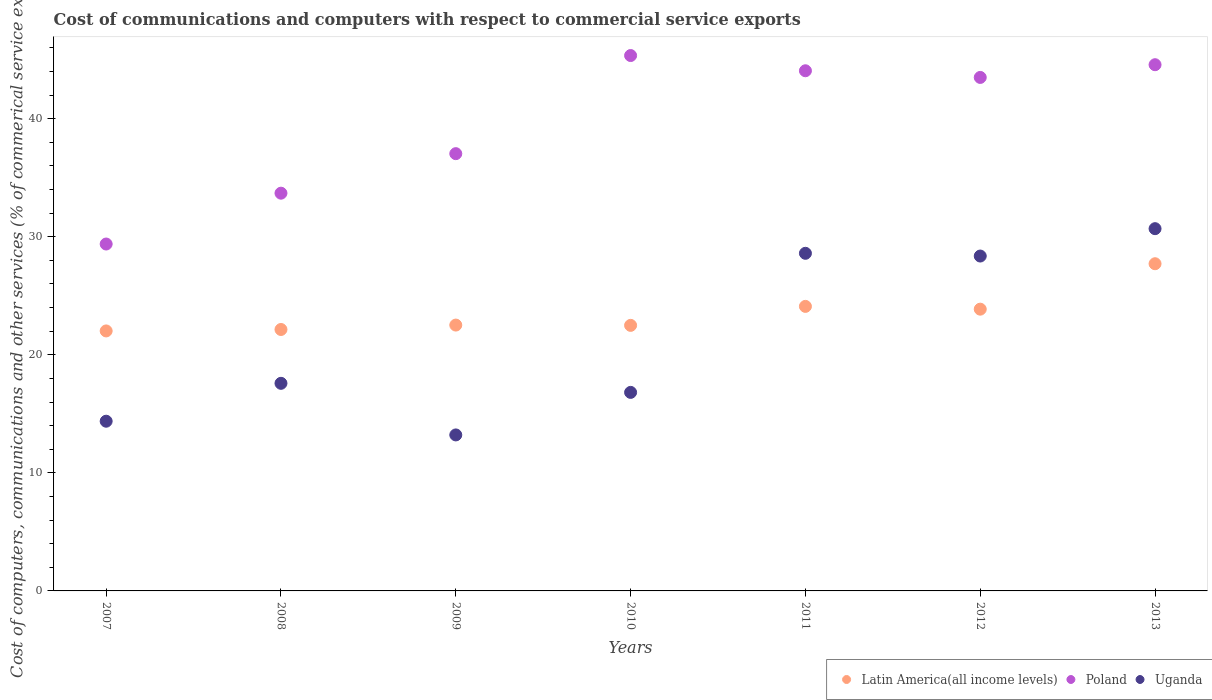How many different coloured dotlines are there?
Provide a succinct answer. 3. What is the cost of communications and computers in Uganda in 2009?
Offer a very short reply. 13.21. Across all years, what is the maximum cost of communications and computers in Uganda?
Provide a succinct answer. 30.69. Across all years, what is the minimum cost of communications and computers in Uganda?
Provide a succinct answer. 13.21. In which year was the cost of communications and computers in Uganda minimum?
Ensure brevity in your answer.  2009. What is the total cost of communications and computers in Latin America(all income levels) in the graph?
Offer a very short reply. 164.87. What is the difference between the cost of communications and computers in Latin America(all income levels) in 2010 and that in 2011?
Your answer should be compact. -1.61. What is the difference between the cost of communications and computers in Uganda in 2013 and the cost of communications and computers in Latin America(all income levels) in 2009?
Your answer should be very brief. 8.17. What is the average cost of communications and computers in Poland per year?
Offer a terse response. 39.66. In the year 2013, what is the difference between the cost of communications and computers in Poland and cost of communications and computers in Uganda?
Provide a short and direct response. 13.89. What is the ratio of the cost of communications and computers in Poland in 2008 to that in 2013?
Ensure brevity in your answer.  0.76. What is the difference between the highest and the second highest cost of communications and computers in Latin America(all income levels)?
Make the answer very short. 3.61. What is the difference between the highest and the lowest cost of communications and computers in Poland?
Provide a succinct answer. 15.97. In how many years, is the cost of communications and computers in Uganda greater than the average cost of communications and computers in Uganda taken over all years?
Your answer should be compact. 3. Is the sum of the cost of communications and computers in Latin America(all income levels) in 2008 and 2012 greater than the maximum cost of communications and computers in Poland across all years?
Give a very brief answer. Yes. Is it the case that in every year, the sum of the cost of communications and computers in Poland and cost of communications and computers in Uganda  is greater than the cost of communications and computers in Latin America(all income levels)?
Your answer should be compact. Yes. Does the cost of communications and computers in Latin America(all income levels) monotonically increase over the years?
Provide a short and direct response. No. Is the cost of communications and computers in Poland strictly greater than the cost of communications and computers in Uganda over the years?
Your answer should be compact. Yes. Is the cost of communications and computers in Poland strictly less than the cost of communications and computers in Uganda over the years?
Provide a succinct answer. No. How many dotlines are there?
Offer a very short reply. 3. How many years are there in the graph?
Offer a very short reply. 7. What is the difference between two consecutive major ticks on the Y-axis?
Your answer should be compact. 10. Where does the legend appear in the graph?
Provide a short and direct response. Bottom right. How are the legend labels stacked?
Keep it short and to the point. Horizontal. What is the title of the graph?
Keep it short and to the point. Cost of communications and computers with respect to commercial service exports. Does "European Union" appear as one of the legend labels in the graph?
Your answer should be compact. No. What is the label or title of the X-axis?
Ensure brevity in your answer.  Years. What is the label or title of the Y-axis?
Make the answer very short. Cost of computers, communications and other services (% of commerical service exports). What is the Cost of computers, communications and other services (% of commerical service exports) of Latin America(all income levels) in 2007?
Keep it short and to the point. 22.02. What is the Cost of computers, communications and other services (% of commerical service exports) in Poland in 2007?
Keep it short and to the point. 29.39. What is the Cost of computers, communications and other services (% of commerical service exports) of Uganda in 2007?
Provide a succinct answer. 14.38. What is the Cost of computers, communications and other services (% of commerical service exports) of Latin America(all income levels) in 2008?
Ensure brevity in your answer.  22.15. What is the Cost of computers, communications and other services (% of commerical service exports) of Poland in 2008?
Your answer should be very brief. 33.69. What is the Cost of computers, communications and other services (% of commerical service exports) of Uganda in 2008?
Give a very brief answer. 17.59. What is the Cost of computers, communications and other services (% of commerical service exports) in Latin America(all income levels) in 2009?
Your answer should be very brief. 22.52. What is the Cost of computers, communications and other services (% of commerical service exports) in Poland in 2009?
Offer a terse response. 37.04. What is the Cost of computers, communications and other services (% of commerical service exports) in Uganda in 2009?
Your answer should be compact. 13.21. What is the Cost of computers, communications and other services (% of commerical service exports) of Latin America(all income levels) in 2010?
Give a very brief answer. 22.5. What is the Cost of computers, communications and other services (% of commerical service exports) of Poland in 2010?
Keep it short and to the point. 45.35. What is the Cost of computers, communications and other services (% of commerical service exports) of Uganda in 2010?
Your answer should be very brief. 16.82. What is the Cost of computers, communications and other services (% of commerical service exports) of Latin America(all income levels) in 2011?
Your answer should be compact. 24.1. What is the Cost of computers, communications and other services (% of commerical service exports) of Poland in 2011?
Make the answer very short. 44.06. What is the Cost of computers, communications and other services (% of commerical service exports) of Uganda in 2011?
Your answer should be compact. 28.6. What is the Cost of computers, communications and other services (% of commerical service exports) of Latin America(all income levels) in 2012?
Give a very brief answer. 23.87. What is the Cost of computers, communications and other services (% of commerical service exports) of Poland in 2012?
Offer a terse response. 43.5. What is the Cost of computers, communications and other services (% of commerical service exports) of Uganda in 2012?
Offer a very short reply. 28.37. What is the Cost of computers, communications and other services (% of commerical service exports) of Latin America(all income levels) in 2013?
Provide a short and direct response. 27.72. What is the Cost of computers, communications and other services (% of commerical service exports) in Poland in 2013?
Provide a succinct answer. 44.58. What is the Cost of computers, communications and other services (% of commerical service exports) of Uganda in 2013?
Give a very brief answer. 30.69. Across all years, what is the maximum Cost of computers, communications and other services (% of commerical service exports) in Latin America(all income levels)?
Provide a short and direct response. 27.72. Across all years, what is the maximum Cost of computers, communications and other services (% of commerical service exports) in Poland?
Provide a short and direct response. 45.35. Across all years, what is the maximum Cost of computers, communications and other services (% of commerical service exports) of Uganda?
Give a very brief answer. 30.69. Across all years, what is the minimum Cost of computers, communications and other services (% of commerical service exports) in Latin America(all income levels)?
Provide a succinct answer. 22.02. Across all years, what is the minimum Cost of computers, communications and other services (% of commerical service exports) of Poland?
Offer a very short reply. 29.39. Across all years, what is the minimum Cost of computers, communications and other services (% of commerical service exports) of Uganda?
Offer a very short reply. 13.21. What is the total Cost of computers, communications and other services (% of commerical service exports) in Latin America(all income levels) in the graph?
Make the answer very short. 164.87. What is the total Cost of computers, communications and other services (% of commerical service exports) in Poland in the graph?
Ensure brevity in your answer.  277.61. What is the total Cost of computers, communications and other services (% of commerical service exports) of Uganda in the graph?
Provide a succinct answer. 149.65. What is the difference between the Cost of computers, communications and other services (% of commerical service exports) in Latin America(all income levels) in 2007 and that in 2008?
Offer a very short reply. -0.12. What is the difference between the Cost of computers, communications and other services (% of commerical service exports) of Poland in 2007 and that in 2008?
Provide a succinct answer. -4.31. What is the difference between the Cost of computers, communications and other services (% of commerical service exports) in Uganda in 2007 and that in 2008?
Offer a terse response. -3.21. What is the difference between the Cost of computers, communications and other services (% of commerical service exports) in Latin America(all income levels) in 2007 and that in 2009?
Offer a terse response. -0.5. What is the difference between the Cost of computers, communications and other services (% of commerical service exports) in Poland in 2007 and that in 2009?
Ensure brevity in your answer.  -7.65. What is the difference between the Cost of computers, communications and other services (% of commerical service exports) of Uganda in 2007 and that in 2009?
Offer a very short reply. 1.16. What is the difference between the Cost of computers, communications and other services (% of commerical service exports) in Latin America(all income levels) in 2007 and that in 2010?
Keep it short and to the point. -0.47. What is the difference between the Cost of computers, communications and other services (% of commerical service exports) in Poland in 2007 and that in 2010?
Give a very brief answer. -15.97. What is the difference between the Cost of computers, communications and other services (% of commerical service exports) of Uganda in 2007 and that in 2010?
Give a very brief answer. -2.44. What is the difference between the Cost of computers, communications and other services (% of commerical service exports) of Latin America(all income levels) in 2007 and that in 2011?
Ensure brevity in your answer.  -2.08. What is the difference between the Cost of computers, communications and other services (% of commerical service exports) in Poland in 2007 and that in 2011?
Give a very brief answer. -14.68. What is the difference between the Cost of computers, communications and other services (% of commerical service exports) in Uganda in 2007 and that in 2011?
Make the answer very short. -14.22. What is the difference between the Cost of computers, communications and other services (% of commerical service exports) in Latin America(all income levels) in 2007 and that in 2012?
Offer a very short reply. -1.84. What is the difference between the Cost of computers, communications and other services (% of commerical service exports) in Poland in 2007 and that in 2012?
Your answer should be compact. -14.11. What is the difference between the Cost of computers, communications and other services (% of commerical service exports) in Uganda in 2007 and that in 2012?
Your answer should be very brief. -13.99. What is the difference between the Cost of computers, communications and other services (% of commerical service exports) of Latin America(all income levels) in 2007 and that in 2013?
Provide a short and direct response. -5.69. What is the difference between the Cost of computers, communications and other services (% of commerical service exports) of Poland in 2007 and that in 2013?
Provide a short and direct response. -15.19. What is the difference between the Cost of computers, communications and other services (% of commerical service exports) in Uganda in 2007 and that in 2013?
Make the answer very short. -16.31. What is the difference between the Cost of computers, communications and other services (% of commerical service exports) in Latin America(all income levels) in 2008 and that in 2009?
Offer a terse response. -0.37. What is the difference between the Cost of computers, communications and other services (% of commerical service exports) of Poland in 2008 and that in 2009?
Provide a short and direct response. -3.35. What is the difference between the Cost of computers, communications and other services (% of commerical service exports) of Uganda in 2008 and that in 2009?
Your response must be concise. 4.37. What is the difference between the Cost of computers, communications and other services (% of commerical service exports) in Latin America(all income levels) in 2008 and that in 2010?
Your answer should be very brief. -0.35. What is the difference between the Cost of computers, communications and other services (% of commerical service exports) of Poland in 2008 and that in 2010?
Ensure brevity in your answer.  -11.66. What is the difference between the Cost of computers, communications and other services (% of commerical service exports) in Uganda in 2008 and that in 2010?
Your response must be concise. 0.77. What is the difference between the Cost of computers, communications and other services (% of commerical service exports) in Latin America(all income levels) in 2008 and that in 2011?
Ensure brevity in your answer.  -1.96. What is the difference between the Cost of computers, communications and other services (% of commerical service exports) of Poland in 2008 and that in 2011?
Keep it short and to the point. -10.37. What is the difference between the Cost of computers, communications and other services (% of commerical service exports) of Uganda in 2008 and that in 2011?
Provide a short and direct response. -11.01. What is the difference between the Cost of computers, communications and other services (% of commerical service exports) of Latin America(all income levels) in 2008 and that in 2012?
Ensure brevity in your answer.  -1.72. What is the difference between the Cost of computers, communications and other services (% of commerical service exports) of Poland in 2008 and that in 2012?
Ensure brevity in your answer.  -9.81. What is the difference between the Cost of computers, communications and other services (% of commerical service exports) in Uganda in 2008 and that in 2012?
Offer a terse response. -10.78. What is the difference between the Cost of computers, communications and other services (% of commerical service exports) in Latin America(all income levels) in 2008 and that in 2013?
Make the answer very short. -5.57. What is the difference between the Cost of computers, communications and other services (% of commerical service exports) in Poland in 2008 and that in 2013?
Provide a short and direct response. -10.88. What is the difference between the Cost of computers, communications and other services (% of commerical service exports) of Uganda in 2008 and that in 2013?
Ensure brevity in your answer.  -13.1. What is the difference between the Cost of computers, communications and other services (% of commerical service exports) in Latin America(all income levels) in 2009 and that in 2010?
Give a very brief answer. 0.02. What is the difference between the Cost of computers, communications and other services (% of commerical service exports) in Poland in 2009 and that in 2010?
Your answer should be very brief. -8.31. What is the difference between the Cost of computers, communications and other services (% of commerical service exports) of Uganda in 2009 and that in 2010?
Ensure brevity in your answer.  -3.6. What is the difference between the Cost of computers, communications and other services (% of commerical service exports) in Latin America(all income levels) in 2009 and that in 2011?
Your answer should be very brief. -1.58. What is the difference between the Cost of computers, communications and other services (% of commerical service exports) of Poland in 2009 and that in 2011?
Keep it short and to the point. -7.02. What is the difference between the Cost of computers, communications and other services (% of commerical service exports) of Uganda in 2009 and that in 2011?
Ensure brevity in your answer.  -15.38. What is the difference between the Cost of computers, communications and other services (% of commerical service exports) of Latin America(all income levels) in 2009 and that in 2012?
Provide a short and direct response. -1.35. What is the difference between the Cost of computers, communications and other services (% of commerical service exports) in Poland in 2009 and that in 2012?
Give a very brief answer. -6.46. What is the difference between the Cost of computers, communications and other services (% of commerical service exports) in Uganda in 2009 and that in 2012?
Your answer should be compact. -15.15. What is the difference between the Cost of computers, communications and other services (% of commerical service exports) of Latin America(all income levels) in 2009 and that in 2013?
Provide a succinct answer. -5.2. What is the difference between the Cost of computers, communications and other services (% of commerical service exports) of Poland in 2009 and that in 2013?
Provide a short and direct response. -7.53. What is the difference between the Cost of computers, communications and other services (% of commerical service exports) in Uganda in 2009 and that in 2013?
Your answer should be compact. -17.47. What is the difference between the Cost of computers, communications and other services (% of commerical service exports) of Latin America(all income levels) in 2010 and that in 2011?
Give a very brief answer. -1.61. What is the difference between the Cost of computers, communications and other services (% of commerical service exports) of Poland in 2010 and that in 2011?
Provide a succinct answer. 1.29. What is the difference between the Cost of computers, communications and other services (% of commerical service exports) in Uganda in 2010 and that in 2011?
Provide a short and direct response. -11.78. What is the difference between the Cost of computers, communications and other services (% of commerical service exports) of Latin America(all income levels) in 2010 and that in 2012?
Give a very brief answer. -1.37. What is the difference between the Cost of computers, communications and other services (% of commerical service exports) in Poland in 2010 and that in 2012?
Offer a very short reply. 1.85. What is the difference between the Cost of computers, communications and other services (% of commerical service exports) of Uganda in 2010 and that in 2012?
Make the answer very short. -11.55. What is the difference between the Cost of computers, communications and other services (% of commerical service exports) of Latin America(all income levels) in 2010 and that in 2013?
Your answer should be very brief. -5.22. What is the difference between the Cost of computers, communications and other services (% of commerical service exports) in Poland in 2010 and that in 2013?
Your answer should be compact. 0.78. What is the difference between the Cost of computers, communications and other services (% of commerical service exports) in Uganda in 2010 and that in 2013?
Provide a short and direct response. -13.87. What is the difference between the Cost of computers, communications and other services (% of commerical service exports) of Latin America(all income levels) in 2011 and that in 2012?
Make the answer very short. 0.24. What is the difference between the Cost of computers, communications and other services (% of commerical service exports) of Poland in 2011 and that in 2012?
Offer a very short reply. 0.56. What is the difference between the Cost of computers, communications and other services (% of commerical service exports) in Uganda in 2011 and that in 2012?
Offer a very short reply. 0.23. What is the difference between the Cost of computers, communications and other services (% of commerical service exports) of Latin America(all income levels) in 2011 and that in 2013?
Your answer should be compact. -3.61. What is the difference between the Cost of computers, communications and other services (% of commerical service exports) of Poland in 2011 and that in 2013?
Ensure brevity in your answer.  -0.51. What is the difference between the Cost of computers, communications and other services (% of commerical service exports) of Uganda in 2011 and that in 2013?
Keep it short and to the point. -2.09. What is the difference between the Cost of computers, communications and other services (% of commerical service exports) of Latin America(all income levels) in 2012 and that in 2013?
Provide a short and direct response. -3.85. What is the difference between the Cost of computers, communications and other services (% of commerical service exports) of Poland in 2012 and that in 2013?
Your answer should be compact. -1.08. What is the difference between the Cost of computers, communications and other services (% of commerical service exports) in Uganda in 2012 and that in 2013?
Make the answer very short. -2.32. What is the difference between the Cost of computers, communications and other services (% of commerical service exports) in Latin America(all income levels) in 2007 and the Cost of computers, communications and other services (% of commerical service exports) in Poland in 2008?
Keep it short and to the point. -11.67. What is the difference between the Cost of computers, communications and other services (% of commerical service exports) of Latin America(all income levels) in 2007 and the Cost of computers, communications and other services (% of commerical service exports) of Uganda in 2008?
Ensure brevity in your answer.  4.44. What is the difference between the Cost of computers, communications and other services (% of commerical service exports) in Poland in 2007 and the Cost of computers, communications and other services (% of commerical service exports) in Uganda in 2008?
Offer a terse response. 11.8. What is the difference between the Cost of computers, communications and other services (% of commerical service exports) of Latin America(all income levels) in 2007 and the Cost of computers, communications and other services (% of commerical service exports) of Poland in 2009?
Offer a very short reply. -15.02. What is the difference between the Cost of computers, communications and other services (% of commerical service exports) of Latin America(all income levels) in 2007 and the Cost of computers, communications and other services (% of commerical service exports) of Uganda in 2009?
Keep it short and to the point. 8.81. What is the difference between the Cost of computers, communications and other services (% of commerical service exports) of Poland in 2007 and the Cost of computers, communications and other services (% of commerical service exports) of Uganda in 2009?
Ensure brevity in your answer.  16.17. What is the difference between the Cost of computers, communications and other services (% of commerical service exports) in Latin America(all income levels) in 2007 and the Cost of computers, communications and other services (% of commerical service exports) in Poland in 2010?
Provide a succinct answer. -23.33. What is the difference between the Cost of computers, communications and other services (% of commerical service exports) in Latin America(all income levels) in 2007 and the Cost of computers, communications and other services (% of commerical service exports) in Uganda in 2010?
Give a very brief answer. 5.21. What is the difference between the Cost of computers, communications and other services (% of commerical service exports) of Poland in 2007 and the Cost of computers, communications and other services (% of commerical service exports) of Uganda in 2010?
Keep it short and to the point. 12.57. What is the difference between the Cost of computers, communications and other services (% of commerical service exports) of Latin America(all income levels) in 2007 and the Cost of computers, communications and other services (% of commerical service exports) of Poland in 2011?
Your answer should be compact. -22.04. What is the difference between the Cost of computers, communications and other services (% of commerical service exports) in Latin America(all income levels) in 2007 and the Cost of computers, communications and other services (% of commerical service exports) in Uganda in 2011?
Your response must be concise. -6.58. What is the difference between the Cost of computers, communications and other services (% of commerical service exports) in Poland in 2007 and the Cost of computers, communications and other services (% of commerical service exports) in Uganda in 2011?
Your answer should be compact. 0.79. What is the difference between the Cost of computers, communications and other services (% of commerical service exports) in Latin America(all income levels) in 2007 and the Cost of computers, communications and other services (% of commerical service exports) in Poland in 2012?
Give a very brief answer. -21.47. What is the difference between the Cost of computers, communications and other services (% of commerical service exports) in Latin America(all income levels) in 2007 and the Cost of computers, communications and other services (% of commerical service exports) in Uganda in 2012?
Offer a very short reply. -6.34. What is the difference between the Cost of computers, communications and other services (% of commerical service exports) of Poland in 2007 and the Cost of computers, communications and other services (% of commerical service exports) of Uganda in 2012?
Ensure brevity in your answer.  1.02. What is the difference between the Cost of computers, communications and other services (% of commerical service exports) in Latin America(all income levels) in 2007 and the Cost of computers, communications and other services (% of commerical service exports) in Poland in 2013?
Keep it short and to the point. -22.55. What is the difference between the Cost of computers, communications and other services (% of commerical service exports) of Latin America(all income levels) in 2007 and the Cost of computers, communications and other services (% of commerical service exports) of Uganda in 2013?
Make the answer very short. -8.66. What is the difference between the Cost of computers, communications and other services (% of commerical service exports) in Poland in 2007 and the Cost of computers, communications and other services (% of commerical service exports) in Uganda in 2013?
Your answer should be very brief. -1.3. What is the difference between the Cost of computers, communications and other services (% of commerical service exports) in Latin America(all income levels) in 2008 and the Cost of computers, communications and other services (% of commerical service exports) in Poland in 2009?
Provide a short and direct response. -14.89. What is the difference between the Cost of computers, communications and other services (% of commerical service exports) in Latin America(all income levels) in 2008 and the Cost of computers, communications and other services (% of commerical service exports) in Uganda in 2009?
Provide a short and direct response. 8.93. What is the difference between the Cost of computers, communications and other services (% of commerical service exports) of Poland in 2008 and the Cost of computers, communications and other services (% of commerical service exports) of Uganda in 2009?
Offer a very short reply. 20.48. What is the difference between the Cost of computers, communications and other services (% of commerical service exports) of Latin America(all income levels) in 2008 and the Cost of computers, communications and other services (% of commerical service exports) of Poland in 2010?
Give a very brief answer. -23.21. What is the difference between the Cost of computers, communications and other services (% of commerical service exports) in Latin America(all income levels) in 2008 and the Cost of computers, communications and other services (% of commerical service exports) in Uganda in 2010?
Your response must be concise. 5.33. What is the difference between the Cost of computers, communications and other services (% of commerical service exports) in Poland in 2008 and the Cost of computers, communications and other services (% of commerical service exports) in Uganda in 2010?
Offer a very short reply. 16.87. What is the difference between the Cost of computers, communications and other services (% of commerical service exports) in Latin America(all income levels) in 2008 and the Cost of computers, communications and other services (% of commerical service exports) in Poland in 2011?
Provide a succinct answer. -21.92. What is the difference between the Cost of computers, communications and other services (% of commerical service exports) of Latin America(all income levels) in 2008 and the Cost of computers, communications and other services (% of commerical service exports) of Uganda in 2011?
Make the answer very short. -6.45. What is the difference between the Cost of computers, communications and other services (% of commerical service exports) in Poland in 2008 and the Cost of computers, communications and other services (% of commerical service exports) in Uganda in 2011?
Your answer should be very brief. 5.09. What is the difference between the Cost of computers, communications and other services (% of commerical service exports) in Latin America(all income levels) in 2008 and the Cost of computers, communications and other services (% of commerical service exports) in Poland in 2012?
Give a very brief answer. -21.35. What is the difference between the Cost of computers, communications and other services (% of commerical service exports) of Latin America(all income levels) in 2008 and the Cost of computers, communications and other services (% of commerical service exports) of Uganda in 2012?
Ensure brevity in your answer.  -6.22. What is the difference between the Cost of computers, communications and other services (% of commerical service exports) in Poland in 2008 and the Cost of computers, communications and other services (% of commerical service exports) in Uganda in 2012?
Ensure brevity in your answer.  5.32. What is the difference between the Cost of computers, communications and other services (% of commerical service exports) of Latin America(all income levels) in 2008 and the Cost of computers, communications and other services (% of commerical service exports) of Poland in 2013?
Your answer should be compact. -22.43. What is the difference between the Cost of computers, communications and other services (% of commerical service exports) in Latin America(all income levels) in 2008 and the Cost of computers, communications and other services (% of commerical service exports) in Uganda in 2013?
Give a very brief answer. -8.54. What is the difference between the Cost of computers, communications and other services (% of commerical service exports) of Poland in 2008 and the Cost of computers, communications and other services (% of commerical service exports) of Uganda in 2013?
Your answer should be very brief. 3.01. What is the difference between the Cost of computers, communications and other services (% of commerical service exports) of Latin America(all income levels) in 2009 and the Cost of computers, communications and other services (% of commerical service exports) of Poland in 2010?
Offer a very short reply. -22.83. What is the difference between the Cost of computers, communications and other services (% of commerical service exports) in Latin America(all income levels) in 2009 and the Cost of computers, communications and other services (% of commerical service exports) in Uganda in 2010?
Keep it short and to the point. 5.7. What is the difference between the Cost of computers, communications and other services (% of commerical service exports) of Poland in 2009 and the Cost of computers, communications and other services (% of commerical service exports) of Uganda in 2010?
Your answer should be compact. 20.22. What is the difference between the Cost of computers, communications and other services (% of commerical service exports) of Latin America(all income levels) in 2009 and the Cost of computers, communications and other services (% of commerical service exports) of Poland in 2011?
Keep it short and to the point. -21.54. What is the difference between the Cost of computers, communications and other services (% of commerical service exports) in Latin America(all income levels) in 2009 and the Cost of computers, communications and other services (% of commerical service exports) in Uganda in 2011?
Give a very brief answer. -6.08. What is the difference between the Cost of computers, communications and other services (% of commerical service exports) in Poland in 2009 and the Cost of computers, communications and other services (% of commerical service exports) in Uganda in 2011?
Ensure brevity in your answer.  8.44. What is the difference between the Cost of computers, communications and other services (% of commerical service exports) in Latin America(all income levels) in 2009 and the Cost of computers, communications and other services (% of commerical service exports) in Poland in 2012?
Ensure brevity in your answer.  -20.98. What is the difference between the Cost of computers, communications and other services (% of commerical service exports) in Latin America(all income levels) in 2009 and the Cost of computers, communications and other services (% of commerical service exports) in Uganda in 2012?
Your answer should be compact. -5.85. What is the difference between the Cost of computers, communications and other services (% of commerical service exports) of Poland in 2009 and the Cost of computers, communications and other services (% of commerical service exports) of Uganda in 2012?
Ensure brevity in your answer.  8.67. What is the difference between the Cost of computers, communications and other services (% of commerical service exports) in Latin America(all income levels) in 2009 and the Cost of computers, communications and other services (% of commerical service exports) in Poland in 2013?
Give a very brief answer. -22.06. What is the difference between the Cost of computers, communications and other services (% of commerical service exports) in Latin America(all income levels) in 2009 and the Cost of computers, communications and other services (% of commerical service exports) in Uganda in 2013?
Keep it short and to the point. -8.17. What is the difference between the Cost of computers, communications and other services (% of commerical service exports) of Poland in 2009 and the Cost of computers, communications and other services (% of commerical service exports) of Uganda in 2013?
Keep it short and to the point. 6.35. What is the difference between the Cost of computers, communications and other services (% of commerical service exports) of Latin America(all income levels) in 2010 and the Cost of computers, communications and other services (% of commerical service exports) of Poland in 2011?
Offer a terse response. -21.57. What is the difference between the Cost of computers, communications and other services (% of commerical service exports) of Latin America(all income levels) in 2010 and the Cost of computers, communications and other services (% of commerical service exports) of Uganda in 2011?
Offer a very short reply. -6.1. What is the difference between the Cost of computers, communications and other services (% of commerical service exports) of Poland in 2010 and the Cost of computers, communications and other services (% of commerical service exports) of Uganda in 2011?
Keep it short and to the point. 16.75. What is the difference between the Cost of computers, communications and other services (% of commerical service exports) in Latin America(all income levels) in 2010 and the Cost of computers, communications and other services (% of commerical service exports) in Poland in 2012?
Your answer should be very brief. -21. What is the difference between the Cost of computers, communications and other services (% of commerical service exports) in Latin America(all income levels) in 2010 and the Cost of computers, communications and other services (% of commerical service exports) in Uganda in 2012?
Offer a very short reply. -5.87. What is the difference between the Cost of computers, communications and other services (% of commerical service exports) of Poland in 2010 and the Cost of computers, communications and other services (% of commerical service exports) of Uganda in 2012?
Provide a succinct answer. 16.98. What is the difference between the Cost of computers, communications and other services (% of commerical service exports) in Latin America(all income levels) in 2010 and the Cost of computers, communications and other services (% of commerical service exports) in Poland in 2013?
Your answer should be compact. -22.08. What is the difference between the Cost of computers, communications and other services (% of commerical service exports) in Latin America(all income levels) in 2010 and the Cost of computers, communications and other services (% of commerical service exports) in Uganda in 2013?
Keep it short and to the point. -8.19. What is the difference between the Cost of computers, communications and other services (% of commerical service exports) in Poland in 2010 and the Cost of computers, communications and other services (% of commerical service exports) in Uganda in 2013?
Make the answer very short. 14.67. What is the difference between the Cost of computers, communications and other services (% of commerical service exports) in Latin America(all income levels) in 2011 and the Cost of computers, communications and other services (% of commerical service exports) in Poland in 2012?
Keep it short and to the point. -19.4. What is the difference between the Cost of computers, communications and other services (% of commerical service exports) in Latin America(all income levels) in 2011 and the Cost of computers, communications and other services (% of commerical service exports) in Uganda in 2012?
Provide a succinct answer. -4.26. What is the difference between the Cost of computers, communications and other services (% of commerical service exports) of Poland in 2011 and the Cost of computers, communications and other services (% of commerical service exports) of Uganda in 2012?
Your response must be concise. 15.69. What is the difference between the Cost of computers, communications and other services (% of commerical service exports) of Latin America(all income levels) in 2011 and the Cost of computers, communications and other services (% of commerical service exports) of Poland in 2013?
Make the answer very short. -20.47. What is the difference between the Cost of computers, communications and other services (% of commerical service exports) of Latin America(all income levels) in 2011 and the Cost of computers, communications and other services (% of commerical service exports) of Uganda in 2013?
Offer a terse response. -6.58. What is the difference between the Cost of computers, communications and other services (% of commerical service exports) in Poland in 2011 and the Cost of computers, communications and other services (% of commerical service exports) in Uganda in 2013?
Your response must be concise. 13.38. What is the difference between the Cost of computers, communications and other services (% of commerical service exports) in Latin America(all income levels) in 2012 and the Cost of computers, communications and other services (% of commerical service exports) in Poland in 2013?
Your response must be concise. -20.71. What is the difference between the Cost of computers, communications and other services (% of commerical service exports) of Latin America(all income levels) in 2012 and the Cost of computers, communications and other services (% of commerical service exports) of Uganda in 2013?
Your response must be concise. -6.82. What is the difference between the Cost of computers, communications and other services (% of commerical service exports) of Poland in 2012 and the Cost of computers, communications and other services (% of commerical service exports) of Uganda in 2013?
Make the answer very short. 12.81. What is the average Cost of computers, communications and other services (% of commerical service exports) in Latin America(all income levels) per year?
Keep it short and to the point. 23.55. What is the average Cost of computers, communications and other services (% of commerical service exports) in Poland per year?
Your response must be concise. 39.66. What is the average Cost of computers, communications and other services (% of commerical service exports) in Uganda per year?
Your answer should be compact. 21.38. In the year 2007, what is the difference between the Cost of computers, communications and other services (% of commerical service exports) of Latin America(all income levels) and Cost of computers, communications and other services (% of commerical service exports) of Poland?
Offer a very short reply. -7.36. In the year 2007, what is the difference between the Cost of computers, communications and other services (% of commerical service exports) of Latin America(all income levels) and Cost of computers, communications and other services (% of commerical service exports) of Uganda?
Your response must be concise. 7.65. In the year 2007, what is the difference between the Cost of computers, communications and other services (% of commerical service exports) in Poland and Cost of computers, communications and other services (% of commerical service exports) in Uganda?
Make the answer very short. 15.01. In the year 2008, what is the difference between the Cost of computers, communications and other services (% of commerical service exports) of Latin America(all income levels) and Cost of computers, communications and other services (% of commerical service exports) of Poland?
Your answer should be very brief. -11.55. In the year 2008, what is the difference between the Cost of computers, communications and other services (% of commerical service exports) in Latin America(all income levels) and Cost of computers, communications and other services (% of commerical service exports) in Uganda?
Keep it short and to the point. 4.56. In the year 2008, what is the difference between the Cost of computers, communications and other services (% of commerical service exports) in Poland and Cost of computers, communications and other services (% of commerical service exports) in Uganda?
Offer a terse response. 16.11. In the year 2009, what is the difference between the Cost of computers, communications and other services (% of commerical service exports) of Latin America(all income levels) and Cost of computers, communications and other services (% of commerical service exports) of Poland?
Your answer should be very brief. -14.52. In the year 2009, what is the difference between the Cost of computers, communications and other services (% of commerical service exports) in Latin America(all income levels) and Cost of computers, communications and other services (% of commerical service exports) in Uganda?
Your answer should be compact. 9.31. In the year 2009, what is the difference between the Cost of computers, communications and other services (% of commerical service exports) of Poland and Cost of computers, communications and other services (% of commerical service exports) of Uganda?
Offer a terse response. 23.83. In the year 2010, what is the difference between the Cost of computers, communications and other services (% of commerical service exports) in Latin America(all income levels) and Cost of computers, communications and other services (% of commerical service exports) in Poland?
Offer a terse response. -22.86. In the year 2010, what is the difference between the Cost of computers, communications and other services (% of commerical service exports) in Latin America(all income levels) and Cost of computers, communications and other services (% of commerical service exports) in Uganda?
Your answer should be very brief. 5.68. In the year 2010, what is the difference between the Cost of computers, communications and other services (% of commerical service exports) in Poland and Cost of computers, communications and other services (% of commerical service exports) in Uganda?
Offer a very short reply. 28.53. In the year 2011, what is the difference between the Cost of computers, communications and other services (% of commerical service exports) of Latin America(all income levels) and Cost of computers, communications and other services (% of commerical service exports) of Poland?
Make the answer very short. -19.96. In the year 2011, what is the difference between the Cost of computers, communications and other services (% of commerical service exports) in Latin America(all income levels) and Cost of computers, communications and other services (% of commerical service exports) in Uganda?
Give a very brief answer. -4.5. In the year 2011, what is the difference between the Cost of computers, communications and other services (% of commerical service exports) of Poland and Cost of computers, communications and other services (% of commerical service exports) of Uganda?
Your answer should be compact. 15.46. In the year 2012, what is the difference between the Cost of computers, communications and other services (% of commerical service exports) of Latin America(all income levels) and Cost of computers, communications and other services (% of commerical service exports) of Poland?
Ensure brevity in your answer.  -19.63. In the year 2012, what is the difference between the Cost of computers, communications and other services (% of commerical service exports) in Latin America(all income levels) and Cost of computers, communications and other services (% of commerical service exports) in Uganda?
Make the answer very short. -4.5. In the year 2012, what is the difference between the Cost of computers, communications and other services (% of commerical service exports) of Poland and Cost of computers, communications and other services (% of commerical service exports) of Uganda?
Give a very brief answer. 15.13. In the year 2013, what is the difference between the Cost of computers, communications and other services (% of commerical service exports) of Latin America(all income levels) and Cost of computers, communications and other services (% of commerical service exports) of Poland?
Provide a short and direct response. -16.86. In the year 2013, what is the difference between the Cost of computers, communications and other services (% of commerical service exports) of Latin America(all income levels) and Cost of computers, communications and other services (% of commerical service exports) of Uganda?
Provide a succinct answer. -2.97. In the year 2013, what is the difference between the Cost of computers, communications and other services (% of commerical service exports) in Poland and Cost of computers, communications and other services (% of commerical service exports) in Uganda?
Keep it short and to the point. 13.89. What is the ratio of the Cost of computers, communications and other services (% of commerical service exports) of Poland in 2007 to that in 2008?
Your answer should be compact. 0.87. What is the ratio of the Cost of computers, communications and other services (% of commerical service exports) in Uganda in 2007 to that in 2008?
Offer a very short reply. 0.82. What is the ratio of the Cost of computers, communications and other services (% of commerical service exports) of Poland in 2007 to that in 2009?
Offer a very short reply. 0.79. What is the ratio of the Cost of computers, communications and other services (% of commerical service exports) in Uganda in 2007 to that in 2009?
Provide a short and direct response. 1.09. What is the ratio of the Cost of computers, communications and other services (% of commerical service exports) in Latin America(all income levels) in 2007 to that in 2010?
Your response must be concise. 0.98. What is the ratio of the Cost of computers, communications and other services (% of commerical service exports) in Poland in 2007 to that in 2010?
Your answer should be very brief. 0.65. What is the ratio of the Cost of computers, communications and other services (% of commerical service exports) of Uganda in 2007 to that in 2010?
Ensure brevity in your answer.  0.85. What is the ratio of the Cost of computers, communications and other services (% of commerical service exports) of Latin America(all income levels) in 2007 to that in 2011?
Your answer should be compact. 0.91. What is the ratio of the Cost of computers, communications and other services (% of commerical service exports) in Poland in 2007 to that in 2011?
Ensure brevity in your answer.  0.67. What is the ratio of the Cost of computers, communications and other services (% of commerical service exports) of Uganda in 2007 to that in 2011?
Ensure brevity in your answer.  0.5. What is the ratio of the Cost of computers, communications and other services (% of commerical service exports) of Latin America(all income levels) in 2007 to that in 2012?
Provide a short and direct response. 0.92. What is the ratio of the Cost of computers, communications and other services (% of commerical service exports) in Poland in 2007 to that in 2012?
Offer a terse response. 0.68. What is the ratio of the Cost of computers, communications and other services (% of commerical service exports) of Uganda in 2007 to that in 2012?
Give a very brief answer. 0.51. What is the ratio of the Cost of computers, communications and other services (% of commerical service exports) of Latin America(all income levels) in 2007 to that in 2013?
Provide a succinct answer. 0.79. What is the ratio of the Cost of computers, communications and other services (% of commerical service exports) in Poland in 2007 to that in 2013?
Provide a short and direct response. 0.66. What is the ratio of the Cost of computers, communications and other services (% of commerical service exports) of Uganda in 2007 to that in 2013?
Keep it short and to the point. 0.47. What is the ratio of the Cost of computers, communications and other services (% of commerical service exports) of Latin America(all income levels) in 2008 to that in 2009?
Your response must be concise. 0.98. What is the ratio of the Cost of computers, communications and other services (% of commerical service exports) of Poland in 2008 to that in 2009?
Offer a terse response. 0.91. What is the ratio of the Cost of computers, communications and other services (% of commerical service exports) of Uganda in 2008 to that in 2009?
Ensure brevity in your answer.  1.33. What is the ratio of the Cost of computers, communications and other services (% of commerical service exports) of Latin America(all income levels) in 2008 to that in 2010?
Provide a short and direct response. 0.98. What is the ratio of the Cost of computers, communications and other services (% of commerical service exports) in Poland in 2008 to that in 2010?
Your response must be concise. 0.74. What is the ratio of the Cost of computers, communications and other services (% of commerical service exports) in Uganda in 2008 to that in 2010?
Offer a terse response. 1.05. What is the ratio of the Cost of computers, communications and other services (% of commerical service exports) of Latin America(all income levels) in 2008 to that in 2011?
Ensure brevity in your answer.  0.92. What is the ratio of the Cost of computers, communications and other services (% of commerical service exports) in Poland in 2008 to that in 2011?
Keep it short and to the point. 0.76. What is the ratio of the Cost of computers, communications and other services (% of commerical service exports) of Uganda in 2008 to that in 2011?
Offer a very short reply. 0.61. What is the ratio of the Cost of computers, communications and other services (% of commerical service exports) of Latin America(all income levels) in 2008 to that in 2012?
Your answer should be very brief. 0.93. What is the ratio of the Cost of computers, communications and other services (% of commerical service exports) of Poland in 2008 to that in 2012?
Make the answer very short. 0.77. What is the ratio of the Cost of computers, communications and other services (% of commerical service exports) in Uganda in 2008 to that in 2012?
Make the answer very short. 0.62. What is the ratio of the Cost of computers, communications and other services (% of commerical service exports) in Latin America(all income levels) in 2008 to that in 2013?
Keep it short and to the point. 0.8. What is the ratio of the Cost of computers, communications and other services (% of commerical service exports) of Poland in 2008 to that in 2013?
Make the answer very short. 0.76. What is the ratio of the Cost of computers, communications and other services (% of commerical service exports) of Uganda in 2008 to that in 2013?
Your answer should be very brief. 0.57. What is the ratio of the Cost of computers, communications and other services (% of commerical service exports) of Poland in 2009 to that in 2010?
Keep it short and to the point. 0.82. What is the ratio of the Cost of computers, communications and other services (% of commerical service exports) of Uganda in 2009 to that in 2010?
Ensure brevity in your answer.  0.79. What is the ratio of the Cost of computers, communications and other services (% of commerical service exports) in Latin America(all income levels) in 2009 to that in 2011?
Make the answer very short. 0.93. What is the ratio of the Cost of computers, communications and other services (% of commerical service exports) in Poland in 2009 to that in 2011?
Keep it short and to the point. 0.84. What is the ratio of the Cost of computers, communications and other services (% of commerical service exports) in Uganda in 2009 to that in 2011?
Offer a very short reply. 0.46. What is the ratio of the Cost of computers, communications and other services (% of commerical service exports) in Latin America(all income levels) in 2009 to that in 2012?
Offer a terse response. 0.94. What is the ratio of the Cost of computers, communications and other services (% of commerical service exports) in Poland in 2009 to that in 2012?
Your answer should be compact. 0.85. What is the ratio of the Cost of computers, communications and other services (% of commerical service exports) of Uganda in 2009 to that in 2012?
Make the answer very short. 0.47. What is the ratio of the Cost of computers, communications and other services (% of commerical service exports) in Latin America(all income levels) in 2009 to that in 2013?
Give a very brief answer. 0.81. What is the ratio of the Cost of computers, communications and other services (% of commerical service exports) in Poland in 2009 to that in 2013?
Your response must be concise. 0.83. What is the ratio of the Cost of computers, communications and other services (% of commerical service exports) in Uganda in 2009 to that in 2013?
Your answer should be very brief. 0.43. What is the ratio of the Cost of computers, communications and other services (% of commerical service exports) in Latin America(all income levels) in 2010 to that in 2011?
Offer a very short reply. 0.93. What is the ratio of the Cost of computers, communications and other services (% of commerical service exports) of Poland in 2010 to that in 2011?
Ensure brevity in your answer.  1.03. What is the ratio of the Cost of computers, communications and other services (% of commerical service exports) of Uganda in 2010 to that in 2011?
Offer a very short reply. 0.59. What is the ratio of the Cost of computers, communications and other services (% of commerical service exports) in Latin America(all income levels) in 2010 to that in 2012?
Make the answer very short. 0.94. What is the ratio of the Cost of computers, communications and other services (% of commerical service exports) of Poland in 2010 to that in 2012?
Offer a very short reply. 1.04. What is the ratio of the Cost of computers, communications and other services (% of commerical service exports) of Uganda in 2010 to that in 2012?
Offer a very short reply. 0.59. What is the ratio of the Cost of computers, communications and other services (% of commerical service exports) of Latin America(all income levels) in 2010 to that in 2013?
Ensure brevity in your answer.  0.81. What is the ratio of the Cost of computers, communications and other services (% of commerical service exports) of Poland in 2010 to that in 2013?
Give a very brief answer. 1.02. What is the ratio of the Cost of computers, communications and other services (% of commerical service exports) of Uganda in 2010 to that in 2013?
Offer a very short reply. 0.55. What is the ratio of the Cost of computers, communications and other services (% of commerical service exports) of Latin America(all income levels) in 2011 to that in 2012?
Offer a very short reply. 1.01. What is the ratio of the Cost of computers, communications and other services (% of commerical service exports) of Poland in 2011 to that in 2012?
Your answer should be compact. 1.01. What is the ratio of the Cost of computers, communications and other services (% of commerical service exports) of Uganda in 2011 to that in 2012?
Provide a short and direct response. 1.01. What is the ratio of the Cost of computers, communications and other services (% of commerical service exports) of Latin America(all income levels) in 2011 to that in 2013?
Your response must be concise. 0.87. What is the ratio of the Cost of computers, communications and other services (% of commerical service exports) of Uganda in 2011 to that in 2013?
Provide a short and direct response. 0.93. What is the ratio of the Cost of computers, communications and other services (% of commerical service exports) in Latin America(all income levels) in 2012 to that in 2013?
Make the answer very short. 0.86. What is the ratio of the Cost of computers, communications and other services (% of commerical service exports) in Poland in 2012 to that in 2013?
Make the answer very short. 0.98. What is the ratio of the Cost of computers, communications and other services (% of commerical service exports) of Uganda in 2012 to that in 2013?
Your answer should be very brief. 0.92. What is the difference between the highest and the second highest Cost of computers, communications and other services (% of commerical service exports) of Latin America(all income levels)?
Provide a short and direct response. 3.61. What is the difference between the highest and the second highest Cost of computers, communications and other services (% of commerical service exports) of Poland?
Provide a short and direct response. 0.78. What is the difference between the highest and the second highest Cost of computers, communications and other services (% of commerical service exports) of Uganda?
Provide a succinct answer. 2.09. What is the difference between the highest and the lowest Cost of computers, communications and other services (% of commerical service exports) in Latin America(all income levels)?
Your answer should be compact. 5.69. What is the difference between the highest and the lowest Cost of computers, communications and other services (% of commerical service exports) in Poland?
Your response must be concise. 15.97. What is the difference between the highest and the lowest Cost of computers, communications and other services (% of commerical service exports) in Uganda?
Offer a terse response. 17.47. 